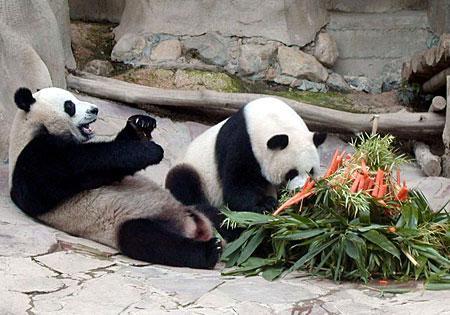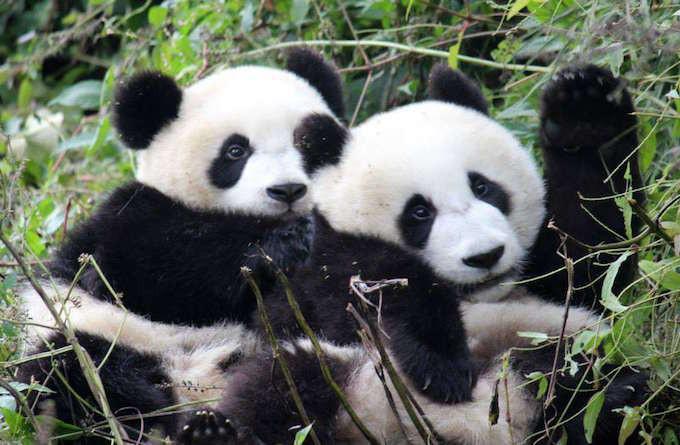The first image is the image on the left, the second image is the image on the right. Given the left and right images, does the statement "Two pandas are playing together in each of the images." hold true? Answer yes or no. Yes. The first image is the image on the left, the second image is the image on the right. Analyze the images presented: Is the assertion "There is a total of three pandas." valid? Answer yes or no. No. 